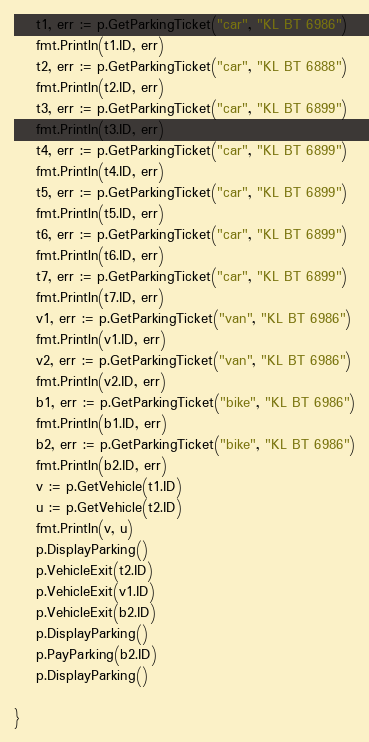<code> <loc_0><loc_0><loc_500><loc_500><_Go_>	t1, err := p.GetParkingTicket("car", "KL BT 6986")
	fmt.Println(t1.ID, err)
	t2, err := p.GetParkingTicket("car", "KL BT 6888")
	fmt.Println(t2.ID, err)
	t3, err := p.GetParkingTicket("car", "KL BT 6899")
	fmt.Println(t3.ID, err)
	t4, err := p.GetParkingTicket("car", "KL BT 6899")
	fmt.Println(t4.ID, err)
	t5, err := p.GetParkingTicket("car", "KL BT 6899")
	fmt.Println(t5.ID, err)
	t6, err := p.GetParkingTicket("car", "KL BT 6899")
	fmt.Println(t6.ID, err)
	t7, err := p.GetParkingTicket("car", "KL BT 6899")
	fmt.Println(t7.ID, err)
	v1, err := p.GetParkingTicket("van", "KL BT 6986")
	fmt.Println(v1.ID, err)
	v2, err := p.GetParkingTicket("van", "KL BT 6986")
	fmt.Println(v2.ID, err)
	b1, err := p.GetParkingTicket("bike", "KL BT 6986")
	fmt.Println(b1.ID, err)
	b2, err := p.GetParkingTicket("bike", "KL BT 6986")
	fmt.Println(b2.ID, err)
	v := p.GetVehicle(t1.ID)
	u := p.GetVehicle(t2.ID)
	fmt.Println(v, u)
	p.DisplayParking()
	p.VehicleExit(t2.ID)
	p.VehicleExit(v1.ID)
	p.VehicleExit(b2.ID)
	p.DisplayParking()
	p.PayParking(b2.ID)
	p.DisplayParking()

}
</code> 